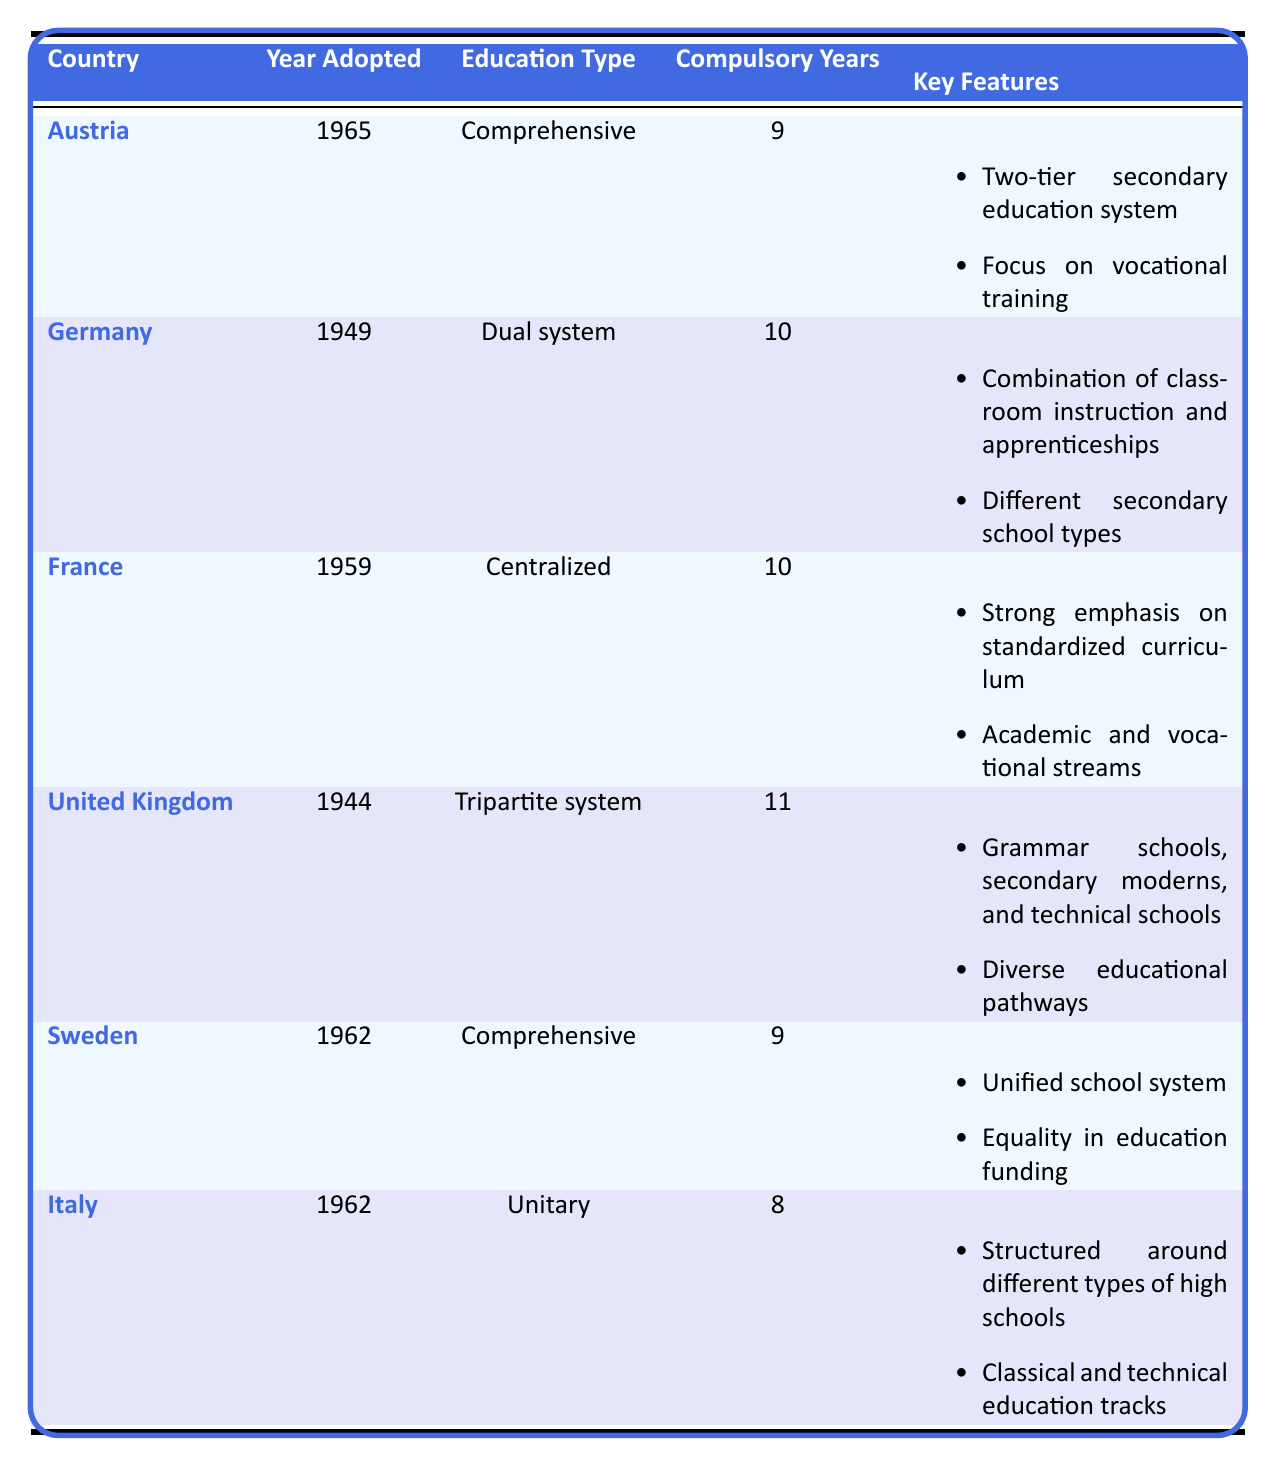What year did Austria adopt its education system? From the table, the row for Austria lists the "Year Adopted" column, which shows 1965.
Answer: 1965 Which country has a dual education system? The table clearly states under the "Education Type" column that Germany has a "Dual system."
Answer: Germany How many years of compulsory education are required in the United Kingdom? In the "Compulsory Education Years" column for the United Kingdom, the entry states that it is 11 years.
Answer: 11 What are the key features of Sweden's education system? The table lists several bullet points for Sweden's "Key Features," including a unified school system and equality in education funding.
Answer: Unified school system and equality in education funding Which two countries adopted their education systems in the year 1962? By inspecting the "Year Adopted" column, both Sweden and Italy have the entry of 1962.
Answer: Sweden and Italy Does France's education system emphasize a standardized curriculum? The table indicates under "Key Features" for France that there is a strong emphasis on standardized curriculum.
Answer: Yes What is the difference in compulsory education years between Germany and Italy? The table shows that Germany has 10 years and Italy has 8 years of compulsory education. Thus, the difference is 10 - 8 = 2 years.
Answer: 2 years Which country's education system was influenced by the 1968 student movement? In the "Notable Influences" for Austria, the influence of the 1968 student movement is mentioned.
Answer: Austria How does the compulsory education duration of Austria compare to that of France? Austria has 9 compulsory education years while France has 10. Therefore, Austria has 1 year less than France.
Answer: 1 year less What was one notable influence on Germany's education system? The table notes several influences on Germany's education system, one of which is "Post-war reconstruction."
Answer: Post-war reconstruction How many countries have a comprehensive education system? Looking at the "Education Type" column, both Austria and Sweden are listed as having a "Comprehensive" education system, hence there are 2 countries.
Answer: 2 countries Is there a country that has a lower number of compulsory education years than Italy? Italy has 8 years; looking through the table, Sweden also has 9, while Austria has 9, Germany and France both have 10, hence there is no country with lower compulsory years than Italy.
Answer: No What can you infer about the socio-political influences on education systems in Belgium based on the data? The table does not include Belgium, so no direct inference can be made regarding its education system based on the presented data.
Answer: Cannot infer 